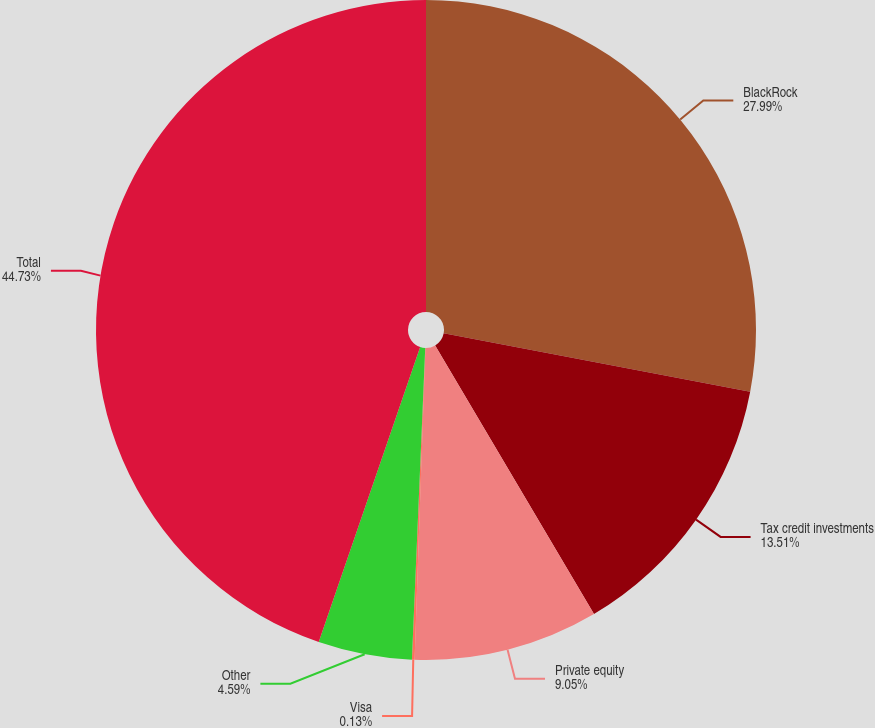<chart> <loc_0><loc_0><loc_500><loc_500><pie_chart><fcel>BlackRock<fcel>Tax credit investments<fcel>Private equity<fcel>Visa<fcel>Other<fcel>Total<nl><fcel>27.99%<fcel>13.51%<fcel>9.05%<fcel>0.13%<fcel>4.59%<fcel>44.73%<nl></chart> 